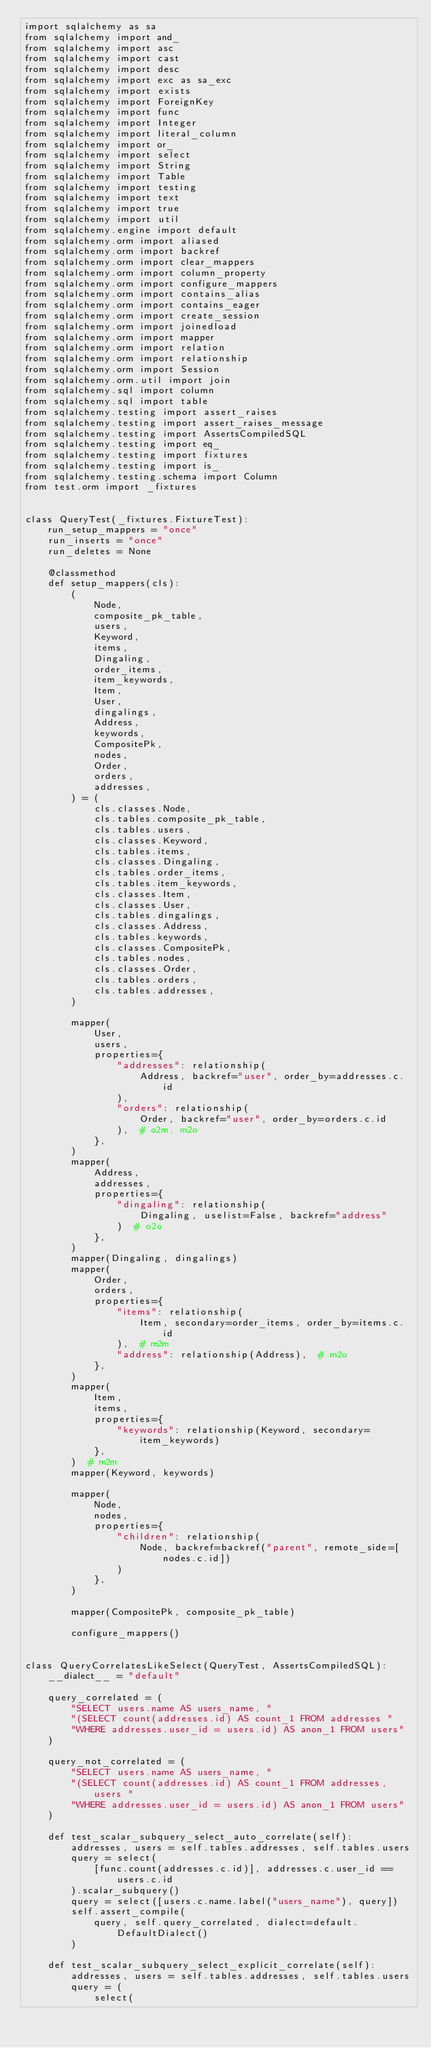<code> <loc_0><loc_0><loc_500><loc_500><_Python_>import sqlalchemy as sa
from sqlalchemy import and_
from sqlalchemy import asc
from sqlalchemy import cast
from sqlalchemy import desc
from sqlalchemy import exc as sa_exc
from sqlalchemy import exists
from sqlalchemy import ForeignKey
from sqlalchemy import func
from sqlalchemy import Integer
from sqlalchemy import literal_column
from sqlalchemy import or_
from sqlalchemy import select
from sqlalchemy import String
from sqlalchemy import Table
from sqlalchemy import testing
from sqlalchemy import text
from sqlalchemy import true
from sqlalchemy import util
from sqlalchemy.engine import default
from sqlalchemy.orm import aliased
from sqlalchemy.orm import backref
from sqlalchemy.orm import clear_mappers
from sqlalchemy.orm import column_property
from sqlalchemy.orm import configure_mappers
from sqlalchemy.orm import contains_alias
from sqlalchemy.orm import contains_eager
from sqlalchemy.orm import create_session
from sqlalchemy.orm import joinedload
from sqlalchemy.orm import mapper
from sqlalchemy.orm import relation
from sqlalchemy.orm import relationship
from sqlalchemy.orm import Session
from sqlalchemy.orm.util import join
from sqlalchemy.sql import column
from sqlalchemy.sql import table
from sqlalchemy.testing import assert_raises
from sqlalchemy.testing import assert_raises_message
from sqlalchemy.testing import AssertsCompiledSQL
from sqlalchemy.testing import eq_
from sqlalchemy.testing import fixtures
from sqlalchemy.testing import is_
from sqlalchemy.testing.schema import Column
from test.orm import _fixtures


class QueryTest(_fixtures.FixtureTest):
    run_setup_mappers = "once"
    run_inserts = "once"
    run_deletes = None

    @classmethod
    def setup_mappers(cls):
        (
            Node,
            composite_pk_table,
            users,
            Keyword,
            items,
            Dingaling,
            order_items,
            item_keywords,
            Item,
            User,
            dingalings,
            Address,
            keywords,
            CompositePk,
            nodes,
            Order,
            orders,
            addresses,
        ) = (
            cls.classes.Node,
            cls.tables.composite_pk_table,
            cls.tables.users,
            cls.classes.Keyword,
            cls.tables.items,
            cls.classes.Dingaling,
            cls.tables.order_items,
            cls.tables.item_keywords,
            cls.classes.Item,
            cls.classes.User,
            cls.tables.dingalings,
            cls.classes.Address,
            cls.tables.keywords,
            cls.classes.CompositePk,
            cls.tables.nodes,
            cls.classes.Order,
            cls.tables.orders,
            cls.tables.addresses,
        )

        mapper(
            User,
            users,
            properties={
                "addresses": relationship(
                    Address, backref="user", order_by=addresses.c.id
                ),
                "orders": relationship(
                    Order, backref="user", order_by=orders.c.id
                ),  # o2m, m2o
            },
        )
        mapper(
            Address,
            addresses,
            properties={
                "dingaling": relationship(
                    Dingaling, uselist=False, backref="address"
                )  # o2o
            },
        )
        mapper(Dingaling, dingalings)
        mapper(
            Order,
            orders,
            properties={
                "items": relationship(
                    Item, secondary=order_items, order_by=items.c.id
                ),  # m2m
                "address": relationship(Address),  # m2o
            },
        )
        mapper(
            Item,
            items,
            properties={
                "keywords": relationship(Keyword, secondary=item_keywords)
            },
        )  # m2m
        mapper(Keyword, keywords)

        mapper(
            Node,
            nodes,
            properties={
                "children": relationship(
                    Node, backref=backref("parent", remote_side=[nodes.c.id])
                )
            },
        )

        mapper(CompositePk, composite_pk_table)

        configure_mappers()


class QueryCorrelatesLikeSelect(QueryTest, AssertsCompiledSQL):
    __dialect__ = "default"

    query_correlated = (
        "SELECT users.name AS users_name, "
        "(SELECT count(addresses.id) AS count_1 FROM addresses "
        "WHERE addresses.user_id = users.id) AS anon_1 FROM users"
    )

    query_not_correlated = (
        "SELECT users.name AS users_name, "
        "(SELECT count(addresses.id) AS count_1 FROM addresses, users "
        "WHERE addresses.user_id = users.id) AS anon_1 FROM users"
    )

    def test_scalar_subquery_select_auto_correlate(self):
        addresses, users = self.tables.addresses, self.tables.users
        query = select(
            [func.count(addresses.c.id)], addresses.c.user_id == users.c.id
        ).scalar_subquery()
        query = select([users.c.name.label("users_name"), query])
        self.assert_compile(
            query, self.query_correlated, dialect=default.DefaultDialect()
        )

    def test_scalar_subquery_select_explicit_correlate(self):
        addresses, users = self.tables.addresses, self.tables.users
        query = (
            select(</code> 